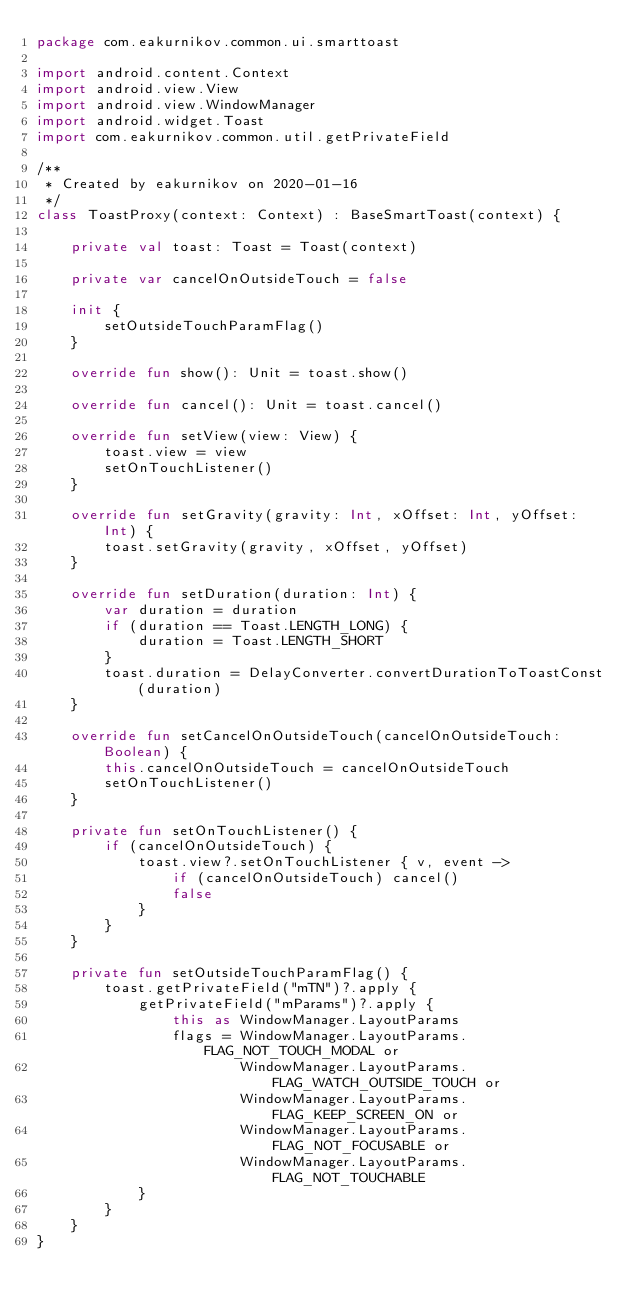Convert code to text. <code><loc_0><loc_0><loc_500><loc_500><_Kotlin_>package com.eakurnikov.common.ui.smarttoast

import android.content.Context
import android.view.View
import android.view.WindowManager
import android.widget.Toast
import com.eakurnikov.common.util.getPrivateField

/**
 * Created by eakurnikov on 2020-01-16
 */
class ToastProxy(context: Context) : BaseSmartToast(context) {

    private val toast: Toast = Toast(context)

    private var cancelOnOutsideTouch = false

    init {
        setOutsideTouchParamFlag()
    }

    override fun show(): Unit = toast.show()

    override fun cancel(): Unit = toast.cancel()

    override fun setView(view: View) {
        toast.view = view
        setOnTouchListener()
    }

    override fun setGravity(gravity: Int, xOffset: Int, yOffset: Int) {
        toast.setGravity(gravity, xOffset, yOffset)
    }

    override fun setDuration(duration: Int) {
        var duration = duration
        if (duration == Toast.LENGTH_LONG) {
            duration = Toast.LENGTH_SHORT
        }
        toast.duration = DelayConverter.convertDurationToToastConst(duration)
    }

    override fun setCancelOnOutsideTouch(cancelOnOutsideTouch: Boolean) {
        this.cancelOnOutsideTouch = cancelOnOutsideTouch
        setOnTouchListener()
    }

    private fun setOnTouchListener() {
        if (cancelOnOutsideTouch) {
            toast.view?.setOnTouchListener { v, event ->
                if (cancelOnOutsideTouch) cancel()
                false
            }
        }
    }

    private fun setOutsideTouchParamFlag() {
        toast.getPrivateField("mTN")?.apply {
            getPrivateField("mParams")?.apply {
                this as WindowManager.LayoutParams
                flags = WindowManager.LayoutParams.FLAG_NOT_TOUCH_MODAL or
                        WindowManager.LayoutParams.FLAG_WATCH_OUTSIDE_TOUCH or
                        WindowManager.LayoutParams.FLAG_KEEP_SCREEN_ON or
                        WindowManager.LayoutParams.FLAG_NOT_FOCUSABLE or
                        WindowManager.LayoutParams.FLAG_NOT_TOUCHABLE
            }
        }
    }
}</code> 